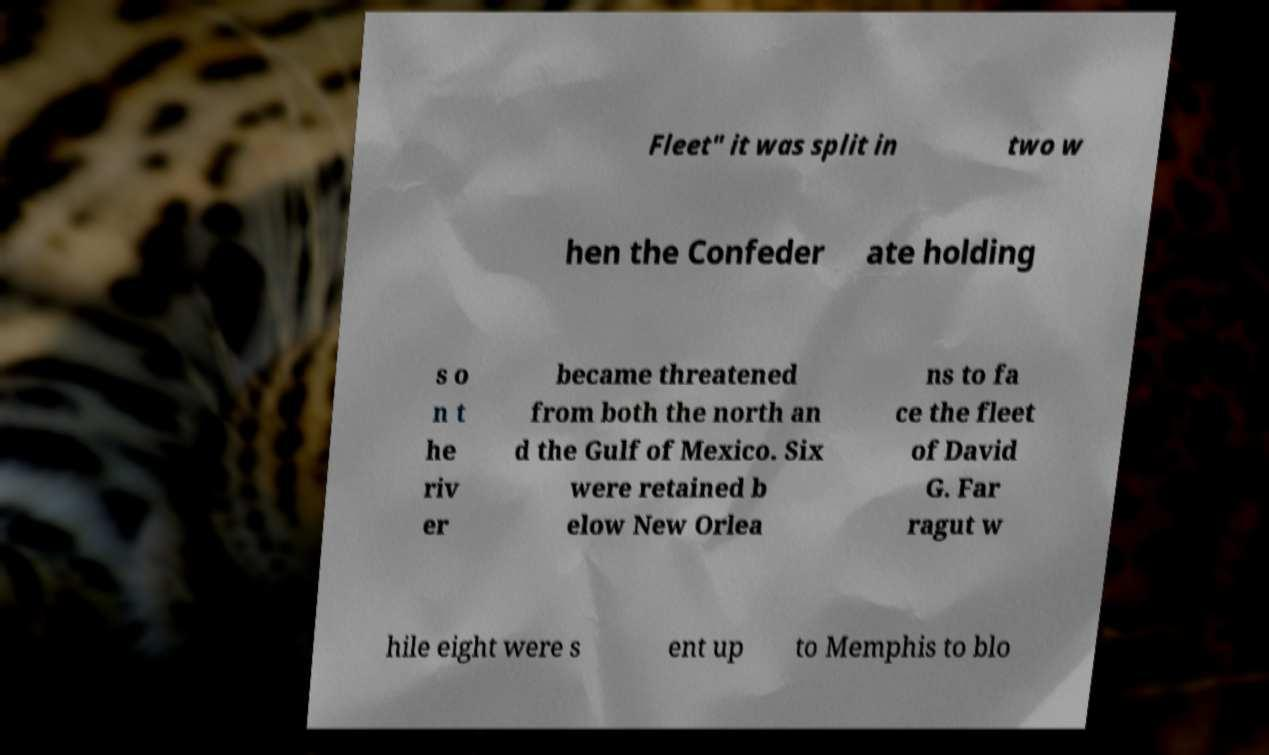What messages or text are displayed in this image? I need them in a readable, typed format. Fleet" it was split in two w hen the Confeder ate holding s o n t he riv er became threatened from both the north an d the Gulf of Mexico. Six were retained b elow New Orlea ns to fa ce the fleet of David G. Far ragut w hile eight were s ent up to Memphis to blo 